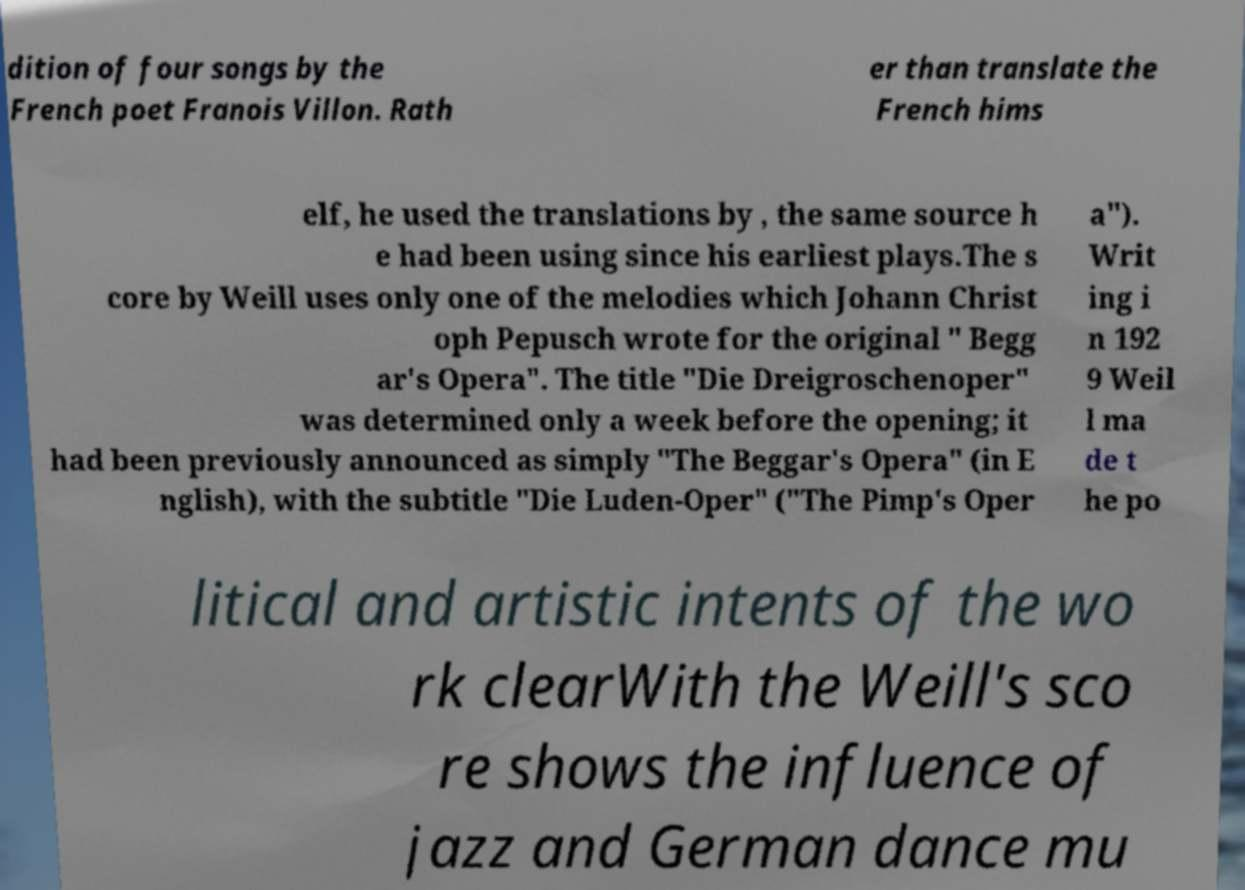What messages or text are displayed in this image? I need them in a readable, typed format. dition of four songs by the French poet Franois Villon. Rath er than translate the French hims elf, he used the translations by , the same source h e had been using since his earliest plays.The s core by Weill uses only one of the melodies which Johann Christ oph Pepusch wrote for the original " Begg ar's Opera". The title "Die Dreigroschenoper" was determined only a week before the opening; it had been previously announced as simply "The Beggar's Opera" (in E nglish), with the subtitle "Die Luden-Oper" ("The Pimp's Oper a"). Writ ing i n 192 9 Weil l ma de t he po litical and artistic intents of the wo rk clearWith the Weill's sco re shows the influence of jazz and German dance mu 